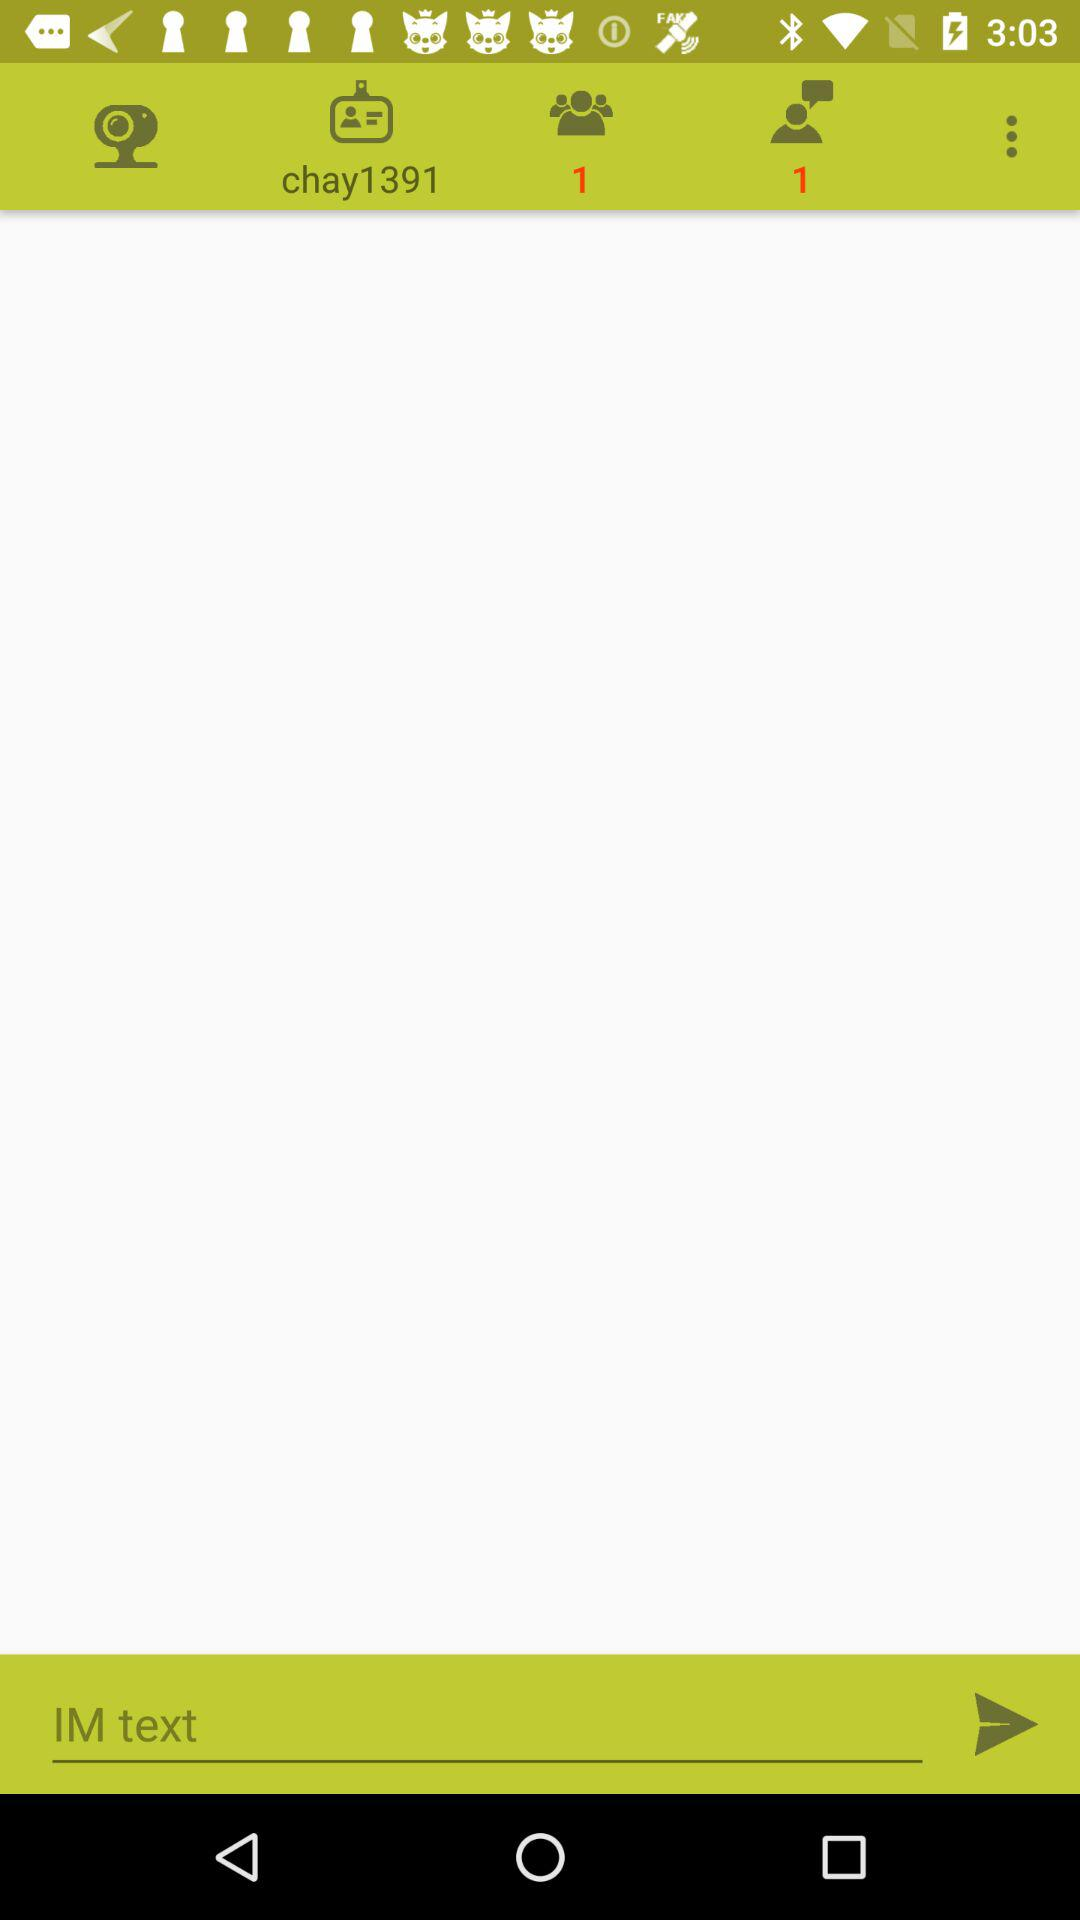What is the number of request?
When the provided information is insufficient, respond with <no answer>. <no answer> 